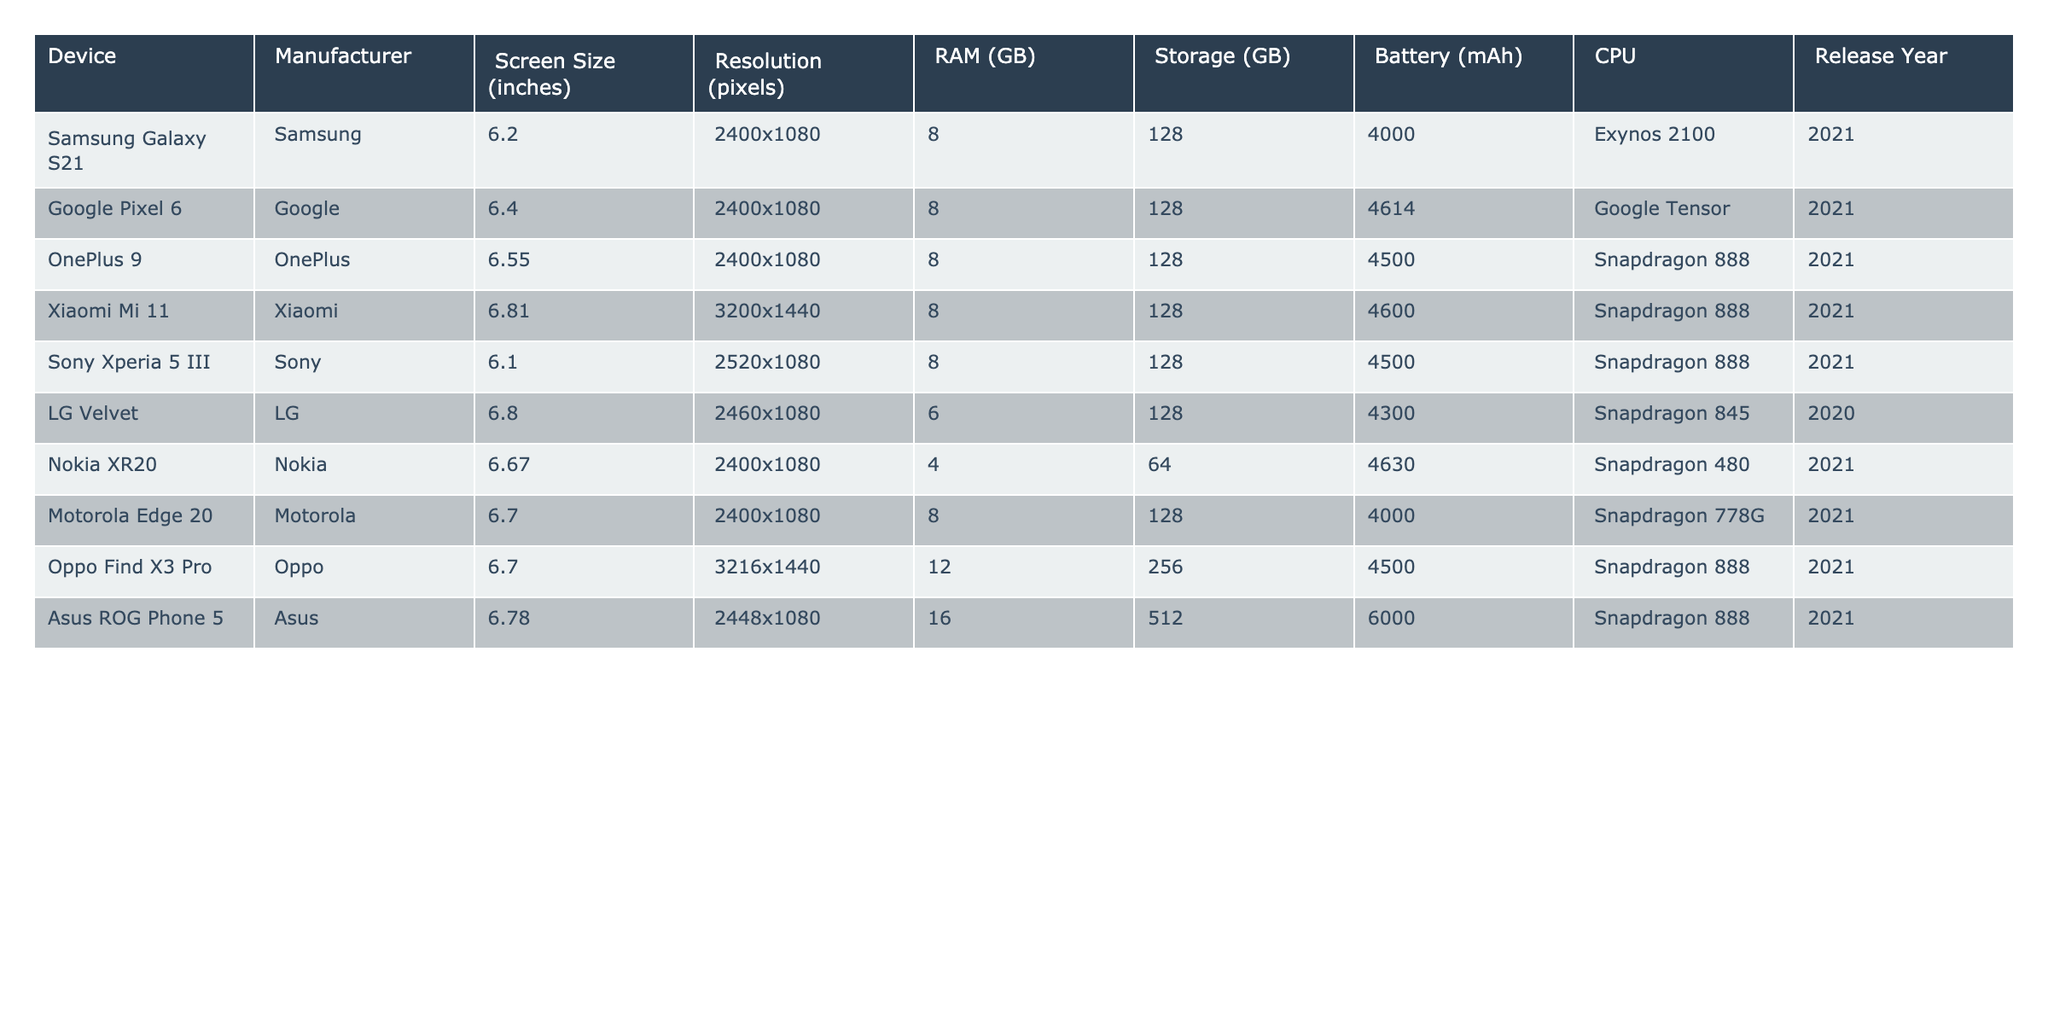What is the screen size of the Google Pixel 6? The Google Pixel 6 entry in the table lists the screen size as 6.4 inches.
Answer: 6.4 inches Which device has the highest RAM? The table shows the Asus ROG Phone 5 with 16 GB of RAM, which is the highest among all listed devices.
Answer: 16 GB Is there a device with a battery capacity of 6000 mAh? The Asus ROG Phone 5 is the only device in the table with a battery capacity of 6000 mAh, confirming a yes to the question.
Answer: Yes What is the average storage capacity of the devices listed? To find the average storage, we add the storage values: 128 + 128 + 128 + 128 + 128 + 64 + 128 + 256 + 512 = 1,024. There are 9 devices, so the average is 1,024 / 9 = approximately 113.78 GB.
Answer: 113.78 GB Which manufacturer has the most devices listed? By counting, Samsung, Google, OnePlus, Xiaomi, Sony, LG, Nokia, Motorola, Oppo, and Asus all appear once, but Asus has the only device counted in this context. Therefore, no manufacturer has more than one device listed in this table.
Answer: No manufacturer has more than one device listed What is the difference in battery capacity between the Nokia XR20 and the Samsung Galaxy S21? The battery capacity of the Nokia XR20 is 4630 mAh, and that of the Samsung Galaxy S21 is 4000 mAh. The difference is 4630 - 4000 = 630 mAh.
Answer: 630 mAh How many devices have a screen size larger than 6.5 inches? The devices with screen sizes larger than 6.5 inches are the OnePlus 9 (6.55), Xiaomi Mi 11 (6.81), and LG Velvet (6.8). So, there are 3 devices.
Answer: 3 What are the release years of the devices that have a Snapdragon 888 CPU? The devices with a Snapdragon 888 CPU are OnePlus 9, Xiaomi Mi 11, Sony Xperia 5 III, Oppo Find X3 Pro, and Asus ROG Phone 5, all released in 2021.
Answer: 2021 Which device has the highest resolution? The Xiaomi Mi 11 and Oppo Find X3 Pro both have the highest resolution of 3200x1440 pixels among all devices in the table.
Answer: 3200x1440 pixels Are there any devices released in 2020? The table shows that the LG Velvet is the only device released in 2020, answering this with a yes.
Answer: Yes 